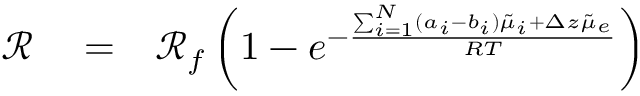Convert formula to latex. <formula><loc_0><loc_0><loc_500><loc_500>\begin{array} { r l r } { \mathcal { R } } & = } & { \mathcal { R } _ { f } \left ( 1 - e ^ { - \frac { \sum _ { i = 1 } ^ { N } ( a _ { i } - b _ { i } ) \tilde { \mu } _ { i } + \Delta z \tilde { \mu } _ { e } } { R T } } \right ) } \end{array}</formula> 